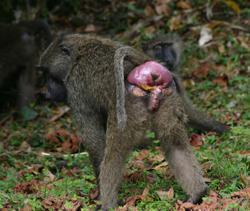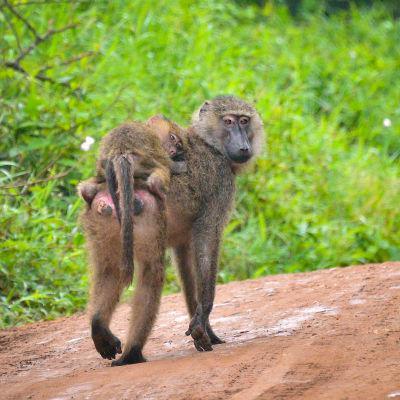The first image is the image on the left, the second image is the image on the right. Considering the images on both sides, is "a baby baboon is riding on its mothers back" valid? Answer yes or no. Yes. The first image is the image on the left, the second image is the image on the right. Assess this claim about the two images: "One of these lesser apes is carrying a younger primate.". Correct or not? Answer yes or no. Yes. 